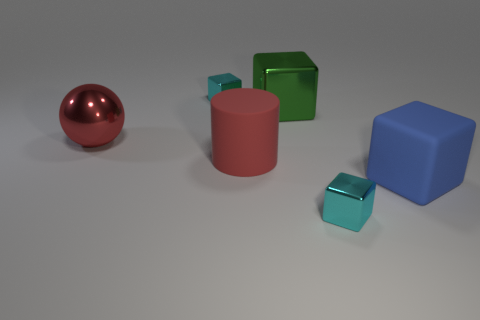Do the red rubber cylinder on the left side of the blue matte cube and the blue cube have the same size?
Your answer should be very brief. Yes. What is the size of the red rubber thing?
Offer a terse response. Large. Are there any large matte cylinders that have the same color as the large matte cube?
Offer a terse response. No. How many small objects are either matte cylinders or cyan metal blocks?
Make the answer very short. 2. How big is the object that is both in front of the large rubber cylinder and to the left of the large rubber cube?
Your answer should be very brief. Small. How many rubber blocks are to the left of the large blue block?
Offer a very short reply. 0. What shape is the metallic object that is in front of the green thing and behind the blue cube?
Ensure brevity in your answer.  Sphere. What is the material of the big cylinder that is the same color as the big ball?
Your response must be concise. Rubber. What number of spheres are large blue objects or cyan shiny objects?
Provide a succinct answer. 0. Are there fewer big red things that are behind the red metallic object than objects?
Your answer should be very brief. Yes. 